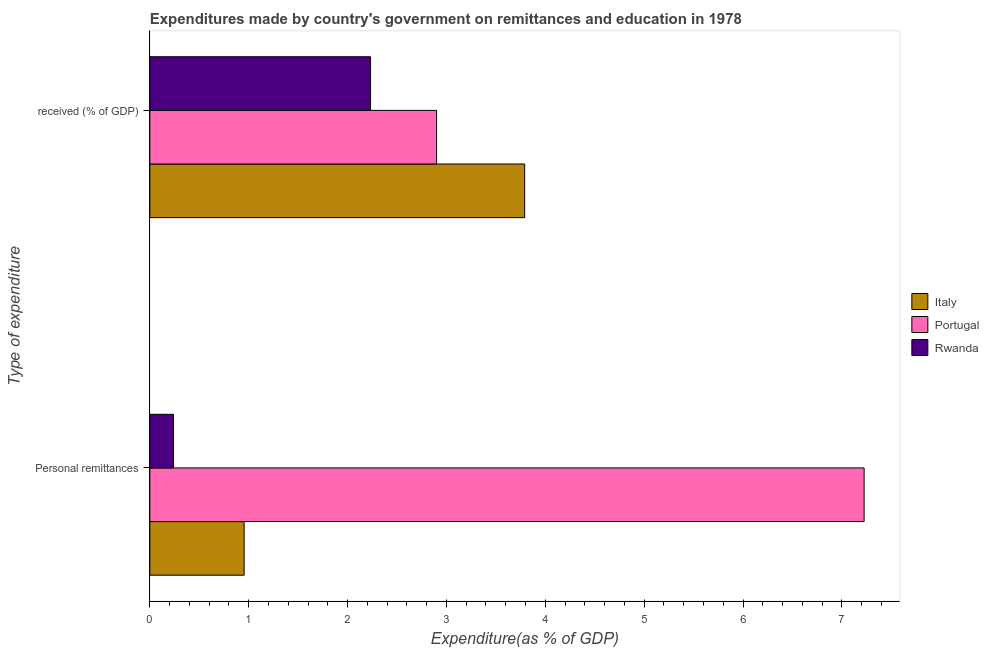Are the number of bars per tick equal to the number of legend labels?
Ensure brevity in your answer.  Yes. How many bars are there on the 2nd tick from the top?
Offer a very short reply. 3. How many bars are there on the 1st tick from the bottom?
Your response must be concise. 3. What is the label of the 2nd group of bars from the top?
Offer a terse response. Personal remittances. What is the expenditure in education in Portugal?
Your answer should be compact. 2.9. Across all countries, what is the maximum expenditure in personal remittances?
Make the answer very short. 7.22. Across all countries, what is the minimum expenditure in personal remittances?
Keep it short and to the point. 0.24. In which country was the expenditure in education maximum?
Keep it short and to the point. Italy. In which country was the expenditure in personal remittances minimum?
Your answer should be compact. Rwanda. What is the total expenditure in personal remittances in the graph?
Offer a very short reply. 8.42. What is the difference between the expenditure in personal remittances in Italy and that in Portugal?
Provide a short and direct response. -6.27. What is the difference between the expenditure in education in Rwanda and the expenditure in personal remittances in Italy?
Offer a terse response. 1.28. What is the average expenditure in education per country?
Make the answer very short. 2.97. What is the difference between the expenditure in personal remittances and expenditure in education in Italy?
Keep it short and to the point. -2.84. What is the ratio of the expenditure in personal remittances in Portugal to that in Italy?
Provide a short and direct response. 7.57. What does the 3rd bar from the top in Personal remittances represents?
Provide a succinct answer. Italy. What does the 3rd bar from the bottom in Personal remittances represents?
Your answer should be very brief. Rwanda. What is the difference between two consecutive major ticks on the X-axis?
Your answer should be very brief. 1. Are the values on the major ticks of X-axis written in scientific E-notation?
Keep it short and to the point. No. Does the graph contain any zero values?
Provide a succinct answer. No. Does the graph contain grids?
Your answer should be very brief. No. How many legend labels are there?
Offer a very short reply. 3. What is the title of the graph?
Provide a short and direct response. Expenditures made by country's government on remittances and education in 1978. Does "Palau" appear as one of the legend labels in the graph?
Ensure brevity in your answer.  No. What is the label or title of the X-axis?
Provide a short and direct response. Expenditure(as % of GDP). What is the label or title of the Y-axis?
Your response must be concise. Type of expenditure. What is the Expenditure(as % of GDP) of Italy in Personal remittances?
Your response must be concise. 0.95. What is the Expenditure(as % of GDP) in Portugal in Personal remittances?
Offer a very short reply. 7.22. What is the Expenditure(as % of GDP) in Rwanda in Personal remittances?
Provide a short and direct response. 0.24. What is the Expenditure(as % of GDP) in Italy in  received (% of GDP)?
Provide a succinct answer. 3.79. What is the Expenditure(as % of GDP) of Portugal in  received (% of GDP)?
Your answer should be very brief. 2.9. What is the Expenditure(as % of GDP) in Rwanda in  received (% of GDP)?
Your answer should be very brief. 2.23. Across all Type of expenditure, what is the maximum Expenditure(as % of GDP) in Italy?
Provide a succinct answer. 3.79. Across all Type of expenditure, what is the maximum Expenditure(as % of GDP) in Portugal?
Keep it short and to the point. 7.22. Across all Type of expenditure, what is the maximum Expenditure(as % of GDP) of Rwanda?
Offer a terse response. 2.23. Across all Type of expenditure, what is the minimum Expenditure(as % of GDP) in Italy?
Ensure brevity in your answer.  0.95. Across all Type of expenditure, what is the minimum Expenditure(as % of GDP) in Portugal?
Make the answer very short. 2.9. Across all Type of expenditure, what is the minimum Expenditure(as % of GDP) of Rwanda?
Ensure brevity in your answer.  0.24. What is the total Expenditure(as % of GDP) of Italy in the graph?
Keep it short and to the point. 4.75. What is the total Expenditure(as % of GDP) of Portugal in the graph?
Your answer should be very brief. 10.12. What is the total Expenditure(as % of GDP) of Rwanda in the graph?
Provide a succinct answer. 2.47. What is the difference between the Expenditure(as % of GDP) of Italy in Personal remittances and that in  received (% of GDP)?
Give a very brief answer. -2.84. What is the difference between the Expenditure(as % of GDP) of Portugal in Personal remittances and that in  received (% of GDP)?
Offer a very short reply. 4.32. What is the difference between the Expenditure(as % of GDP) of Rwanda in Personal remittances and that in  received (% of GDP)?
Make the answer very short. -1.99. What is the difference between the Expenditure(as % of GDP) of Italy in Personal remittances and the Expenditure(as % of GDP) of Portugal in  received (% of GDP)?
Make the answer very short. -1.95. What is the difference between the Expenditure(as % of GDP) of Italy in Personal remittances and the Expenditure(as % of GDP) of Rwanda in  received (% of GDP)?
Keep it short and to the point. -1.28. What is the difference between the Expenditure(as % of GDP) in Portugal in Personal remittances and the Expenditure(as % of GDP) in Rwanda in  received (% of GDP)?
Provide a succinct answer. 4.99. What is the average Expenditure(as % of GDP) in Italy per Type of expenditure?
Your response must be concise. 2.37. What is the average Expenditure(as % of GDP) in Portugal per Type of expenditure?
Ensure brevity in your answer.  5.06. What is the average Expenditure(as % of GDP) of Rwanda per Type of expenditure?
Keep it short and to the point. 1.24. What is the difference between the Expenditure(as % of GDP) in Italy and Expenditure(as % of GDP) in Portugal in Personal remittances?
Your response must be concise. -6.27. What is the difference between the Expenditure(as % of GDP) of Italy and Expenditure(as % of GDP) of Rwanda in Personal remittances?
Your response must be concise. 0.71. What is the difference between the Expenditure(as % of GDP) of Portugal and Expenditure(as % of GDP) of Rwanda in Personal remittances?
Your response must be concise. 6.99. What is the difference between the Expenditure(as % of GDP) in Italy and Expenditure(as % of GDP) in Portugal in  received (% of GDP)?
Your answer should be very brief. 0.89. What is the difference between the Expenditure(as % of GDP) in Italy and Expenditure(as % of GDP) in Rwanda in  received (% of GDP)?
Your answer should be compact. 1.56. What is the difference between the Expenditure(as % of GDP) in Portugal and Expenditure(as % of GDP) in Rwanda in  received (% of GDP)?
Your answer should be compact. 0.67. What is the ratio of the Expenditure(as % of GDP) in Italy in Personal remittances to that in  received (% of GDP)?
Offer a terse response. 0.25. What is the ratio of the Expenditure(as % of GDP) in Portugal in Personal remittances to that in  received (% of GDP)?
Make the answer very short. 2.49. What is the ratio of the Expenditure(as % of GDP) in Rwanda in Personal remittances to that in  received (% of GDP)?
Your answer should be very brief. 0.11. What is the difference between the highest and the second highest Expenditure(as % of GDP) of Italy?
Your answer should be compact. 2.84. What is the difference between the highest and the second highest Expenditure(as % of GDP) of Portugal?
Your answer should be very brief. 4.32. What is the difference between the highest and the second highest Expenditure(as % of GDP) in Rwanda?
Keep it short and to the point. 1.99. What is the difference between the highest and the lowest Expenditure(as % of GDP) in Italy?
Your answer should be very brief. 2.84. What is the difference between the highest and the lowest Expenditure(as % of GDP) in Portugal?
Make the answer very short. 4.32. What is the difference between the highest and the lowest Expenditure(as % of GDP) of Rwanda?
Keep it short and to the point. 1.99. 